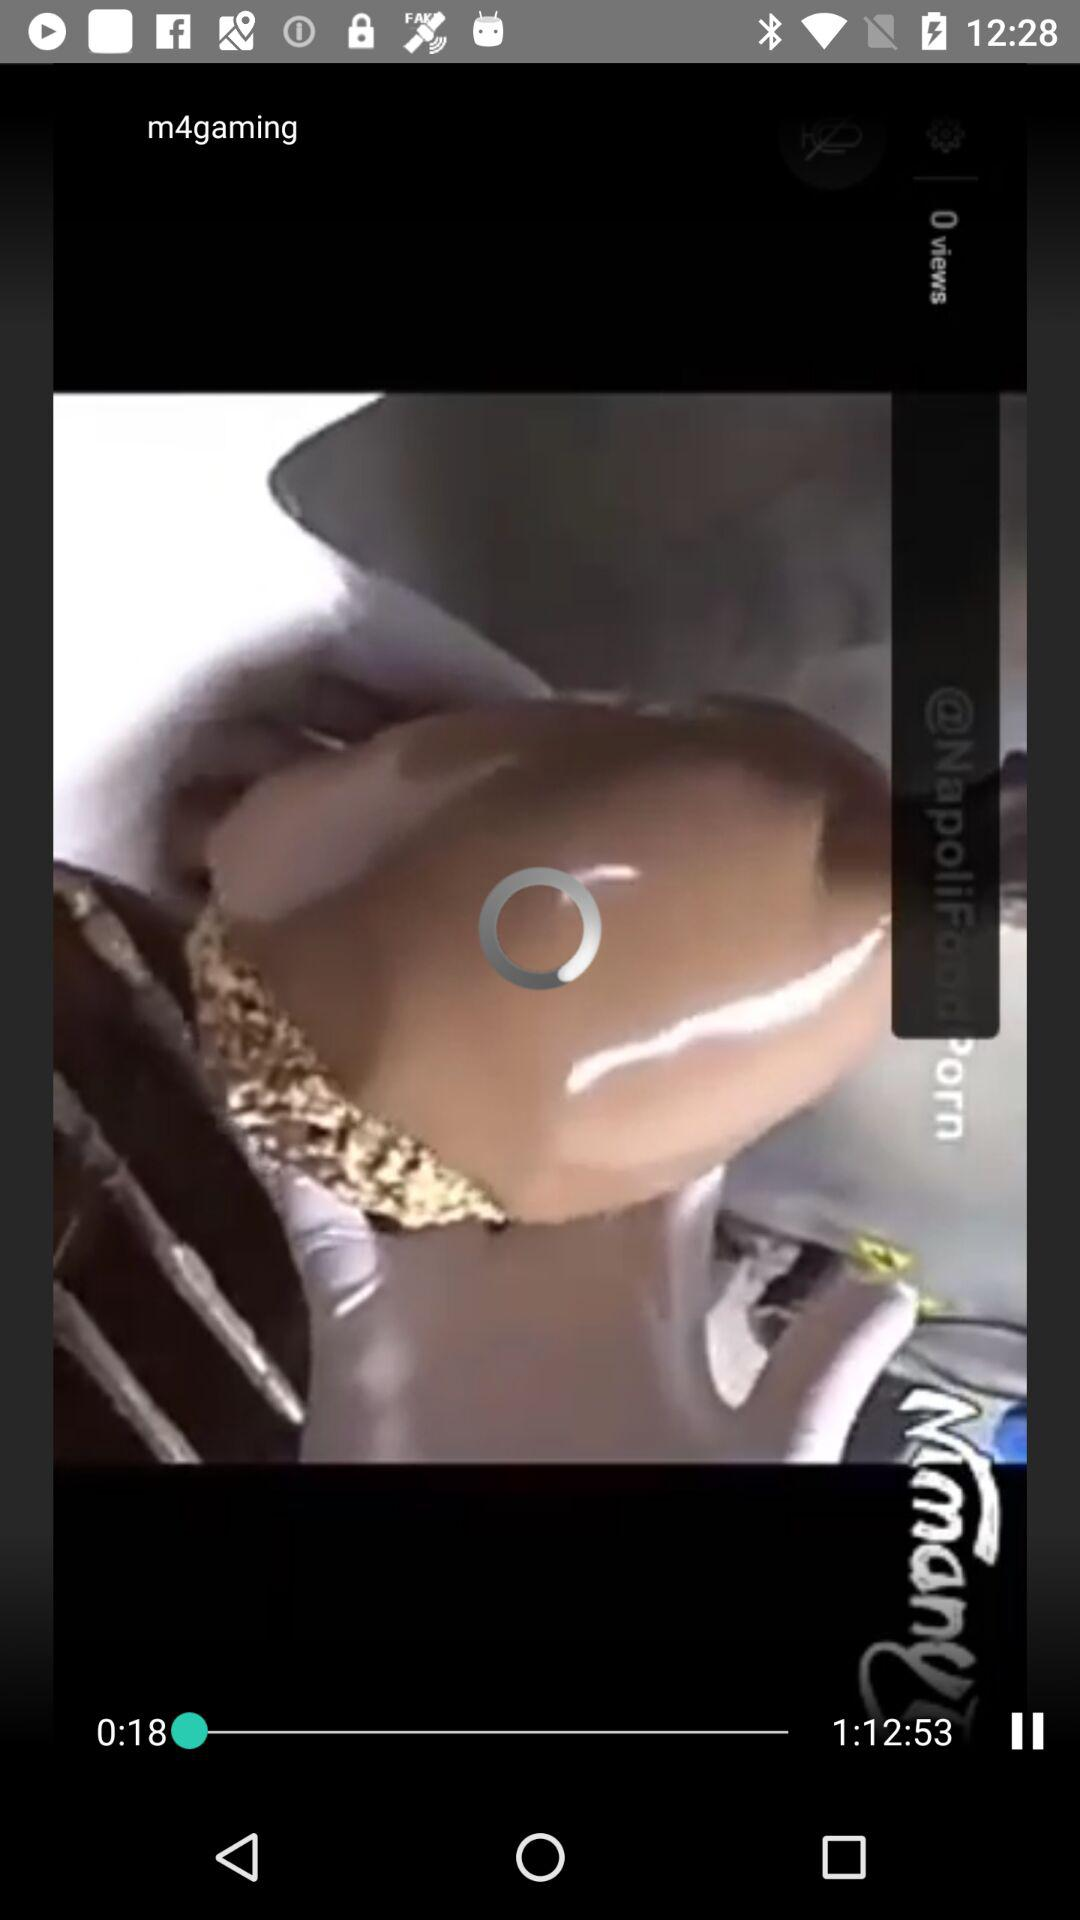Which WiFi connection is used?
When the provided information is insufficient, respond with <no answer>. <no answer> 